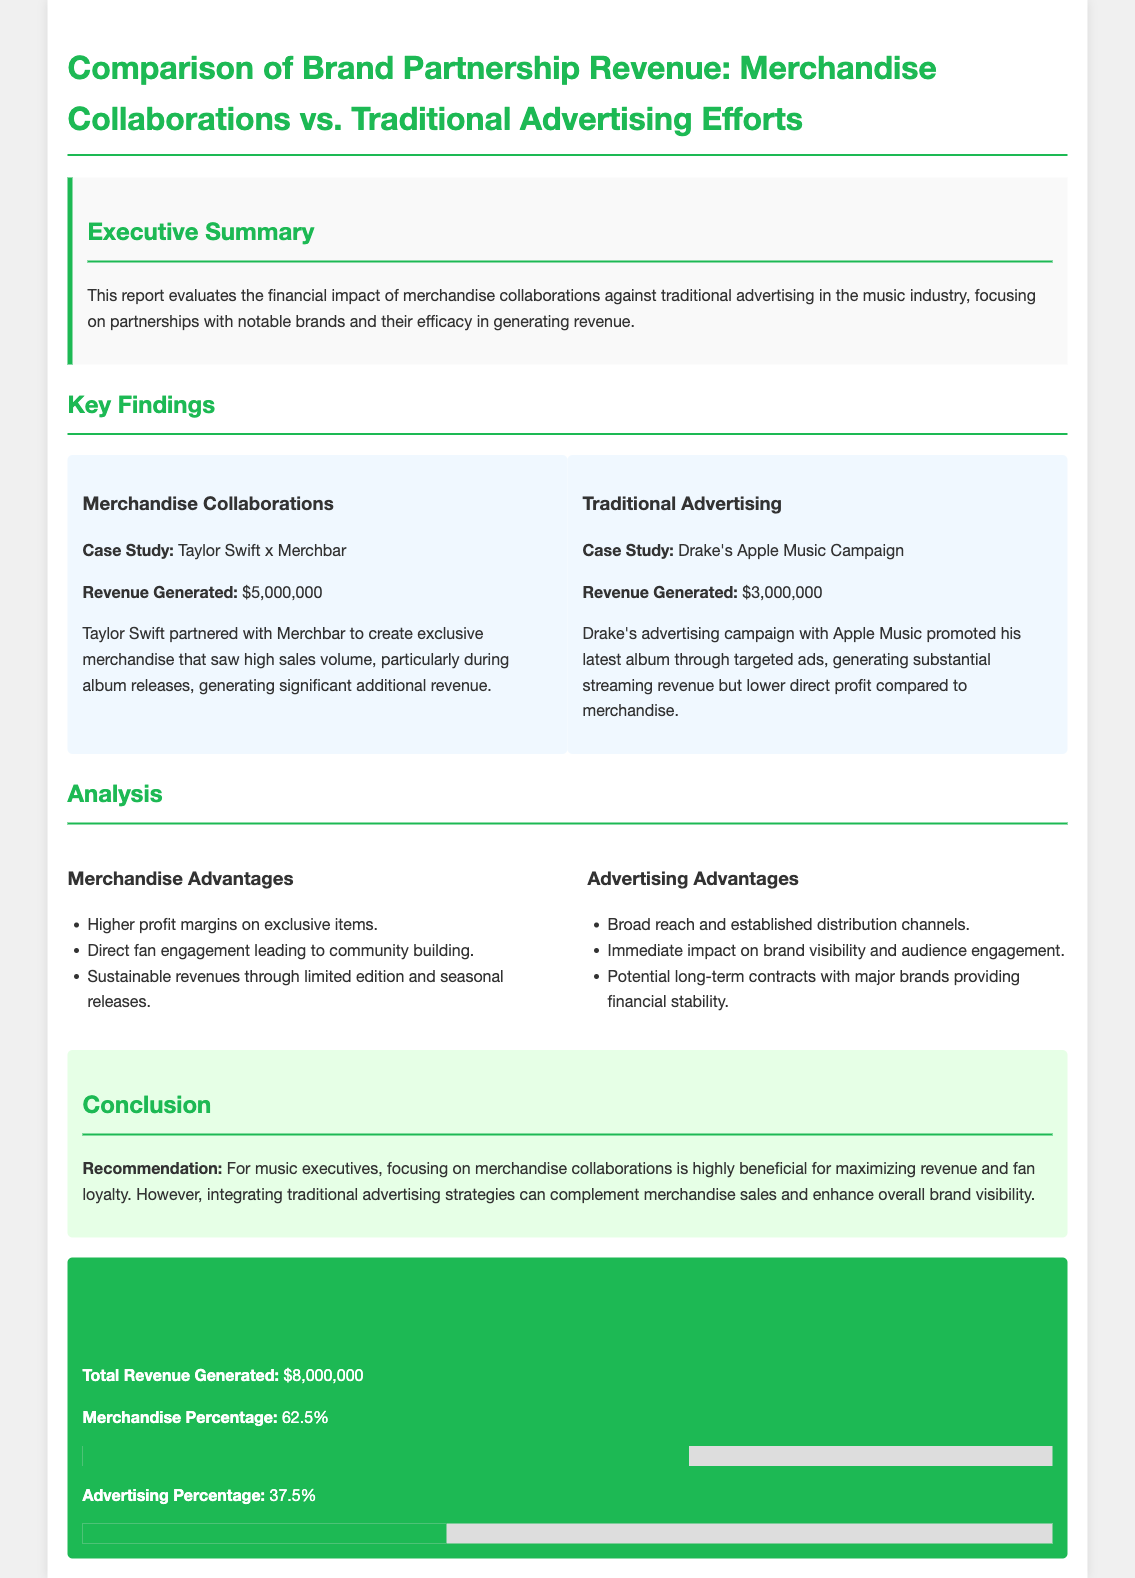What is the revenue generated from merchandise collaborations? The revenue generated from merchandise collaborations as listed in the document is specifically from the Taylor Swift x Merchbar case study.
Answer: $5,000,000 What is the revenue generated from traditional advertising efforts? The revenue generated from traditional advertising is highlighted in the Drake's Apple Music campaign case study in the document.
Answer: $3,000,000 What percentage of total revenue comes from merchandise? The document specifies that merchandise contributes a percentage of the total revenue generated.
Answer: 62.5% What is the total revenue generated from both sources? The document provides a summarized figure representing the total revenue generated from merchandise and traditional advertising.
Answer: $8,000,000 Which partnership is cited for merchandise collaborations? The document mentions a particular case study that exemplifies merchandise collaborations, identifying a specific artist and brand.
Answer: Taylor Swift x Merchbar What are two advantages listed for merchandise collaborations? The document outlines the advantages of merchandise collaborations; two are specifically highlighted in the analysis section.
Answer: Higher profit margins, Direct fan engagement What are two advantages listed for traditional advertising? Similar to merchandise, the document describes certain benefits of traditional advertising, providing multiple examples.
Answer: Broad reach, Immediate impact What is the title of this financial document? The title reflects the main subject of the document, focusing on different types of revenue generation in the music industry.
Answer: Comparison of Brand Partnership Revenue: Merchandise Collaborations vs. Traditional Advertising Efforts What is the case study cited for traditional advertising? The document identifies a specific case that serves as an example of traditional advertising within the music industry context.
Answer: Drake's Apple Music Campaign 